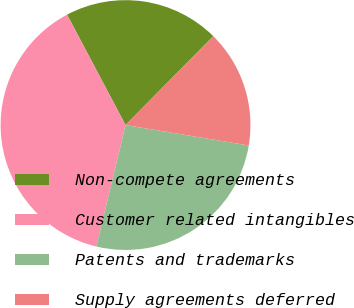Convert chart. <chart><loc_0><loc_0><loc_500><loc_500><pie_chart><fcel>Non-compete agreements<fcel>Customer related intangibles<fcel>Patents and trademarks<fcel>Supply agreements deferred<nl><fcel>20.16%<fcel>38.49%<fcel>26.14%<fcel>15.21%<nl></chart> 